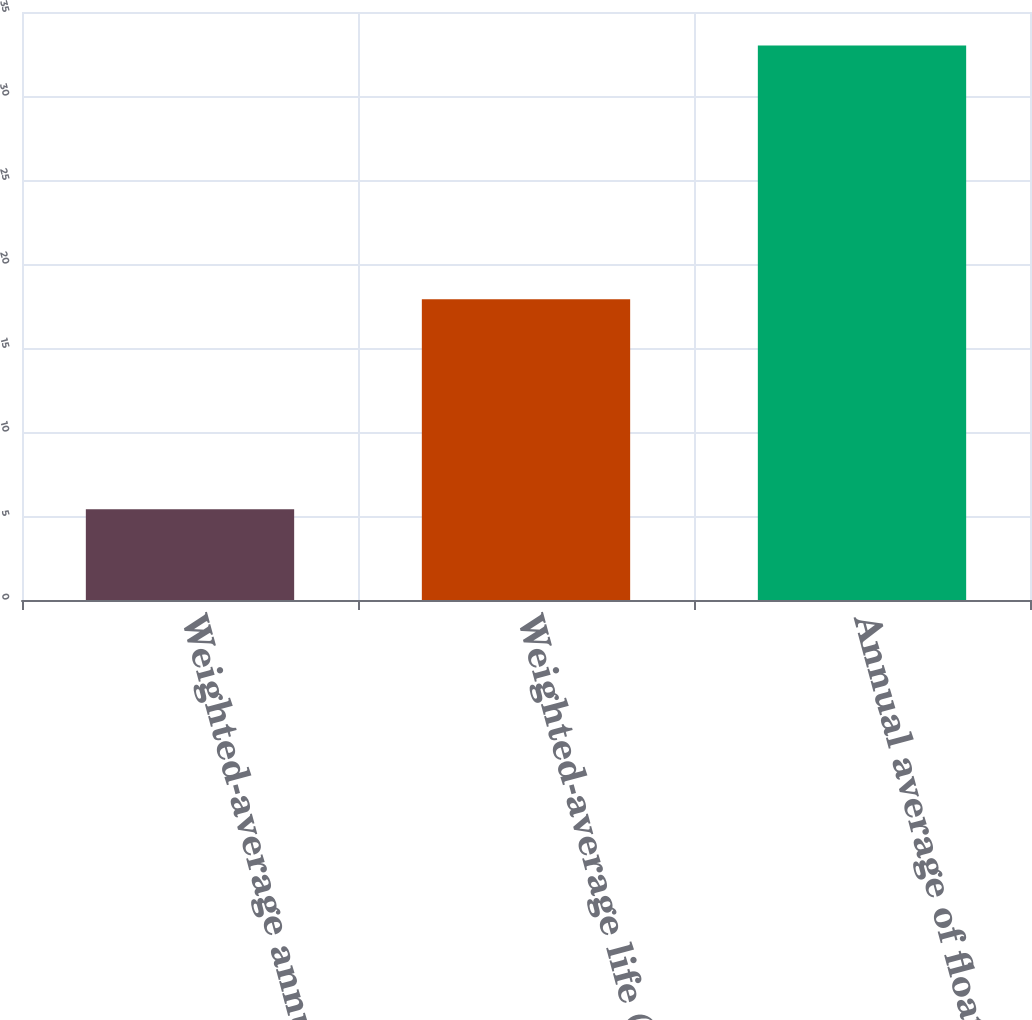<chart> <loc_0><loc_0><loc_500><loc_500><bar_chart><fcel>Weighted-average annual<fcel>Weighted-average life (years)<fcel>Annual average of floating<nl><fcel>5.4<fcel>17.9<fcel>33<nl></chart> 